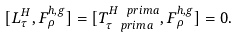<formula> <loc_0><loc_0><loc_500><loc_500>[ L _ { \tau } ^ { H } , F _ { \rho } ^ { h , g } ] = [ T _ { \tau \ p r i m a } ^ { H \ p r i m a } , F _ { \rho } ^ { h , g } ] = 0 .</formula> 